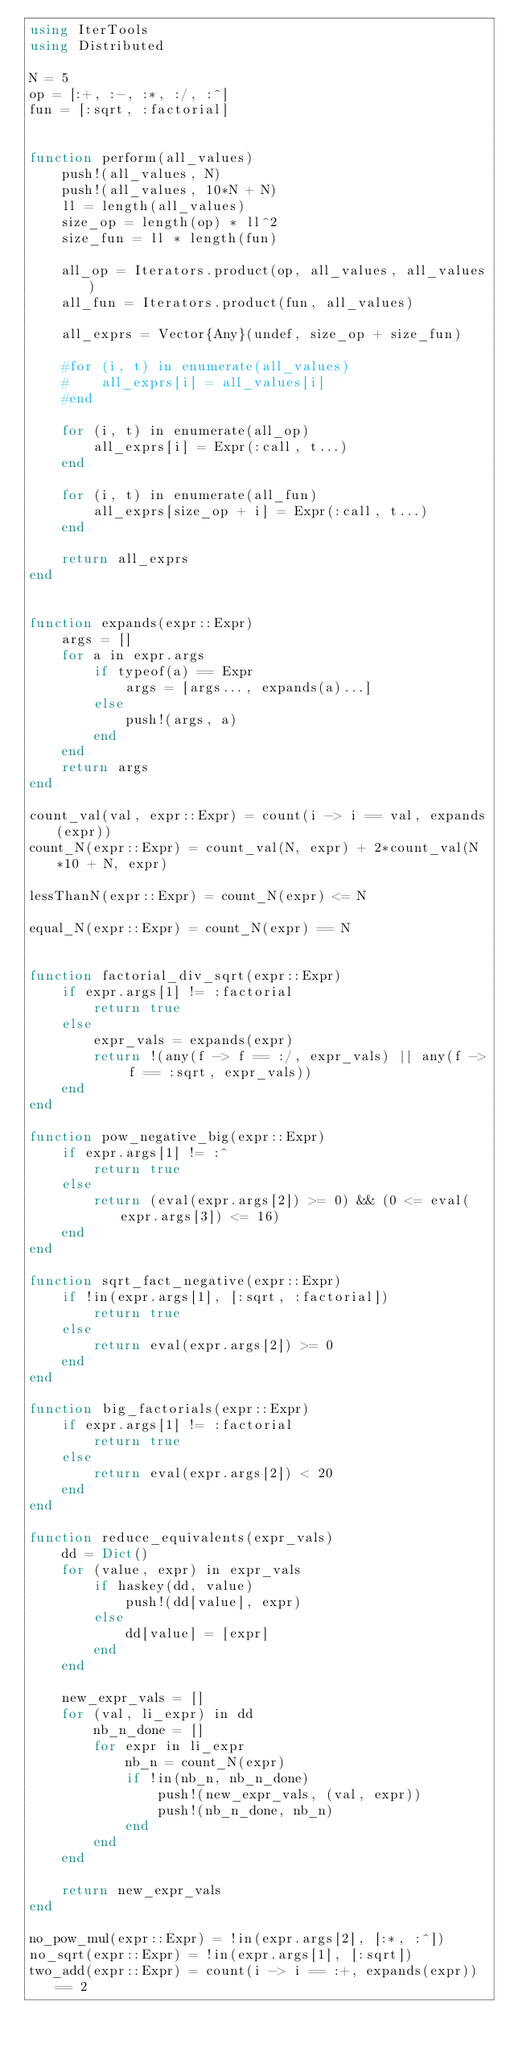Convert code to text. <code><loc_0><loc_0><loc_500><loc_500><_Julia_>using IterTools
using Distributed

N = 5
op = [:+, :-, :*, :/, :^]
fun = [:sqrt, :factorial]


function perform(all_values)
    push!(all_values, N)
    push!(all_values, 10*N + N)
    ll = length(all_values)
    size_op = length(op) * ll^2
    size_fun = ll * length(fun)

    all_op = Iterators.product(op, all_values, all_values)
    all_fun = Iterators.product(fun, all_values)

    all_exprs = Vector{Any}(undef, size_op + size_fun)

    #for (i, t) in enumerate(all_values)
    #    all_exprs[i] = all_values[i]
    #end

    for (i, t) in enumerate(all_op)
        all_exprs[i] = Expr(:call, t...)
    end

    for (i, t) in enumerate(all_fun)
        all_exprs[size_op + i] = Expr(:call, t...)
    end

    return all_exprs
end


function expands(expr::Expr)
    args = []
    for a in expr.args
        if typeof(a) == Expr
            args = [args..., expands(a)...]
        else
            push!(args, a)
        end
    end
    return args 
end

count_val(val, expr::Expr) = count(i -> i == val, expands(expr))
count_N(expr::Expr) = count_val(N, expr) + 2*count_val(N*10 + N, expr)

lessThanN(expr::Expr) = count_N(expr) <= N

equal_N(expr::Expr) = count_N(expr) == N


function factorial_div_sqrt(expr::Expr)
    if expr.args[1] != :factorial
        return true
    else
        expr_vals = expands(expr)
        return !(any(f -> f == :/, expr_vals) || any(f -> f == :sqrt, expr_vals))
    end
end

function pow_negative_big(expr::Expr)
    if expr.args[1] != :^
        return true
    else
        return (eval(expr.args[2]) >= 0) && (0 <= eval(expr.args[3]) <= 16)
    end
end

function sqrt_fact_negative(expr::Expr)
    if !in(expr.args[1], [:sqrt, :factorial])
        return true
    else
        return eval(expr.args[2]) >= 0
    end
end 

function big_factorials(expr::Expr)
    if expr.args[1] != :factorial
        return true
    else
        return eval(expr.args[2]) < 20
    end
end

function reduce_equivalents(expr_vals)
    dd = Dict()
    for (value, expr) in expr_vals
        if haskey(dd, value)
            push!(dd[value], expr)
        else
            dd[value] = [expr]
        end
    end

    new_expr_vals = []
    for (val, li_expr) in dd
        nb_n_done = []
        for expr in li_expr
            nb_n = count_N(expr)
            if !in(nb_n, nb_n_done)
                push!(new_expr_vals, (val, expr))
                push!(nb_n_done, nb_n)
            end
        end
    end

    return new_expr_vals
end

no_pow_mul(expr::Expr) = !in(expr.args[2], [:*, :^])
no_sqrt(expr::Expr) = !in(expr.args[1], [:sqrt])
two_add(expr::Expr) = count(i -> i == :+, expands(expr)) == 2</code> 